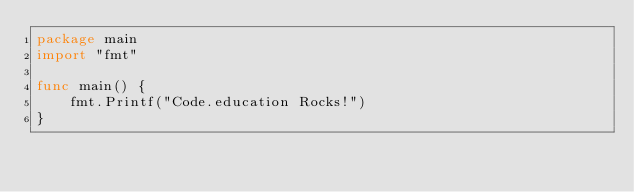<code> <loc_0><loc_0><loc_500><loc_500><_Go_>package main
import "fmt"

func main() {
    fmt.Printf("Code.education Rocks!")
}</code> 